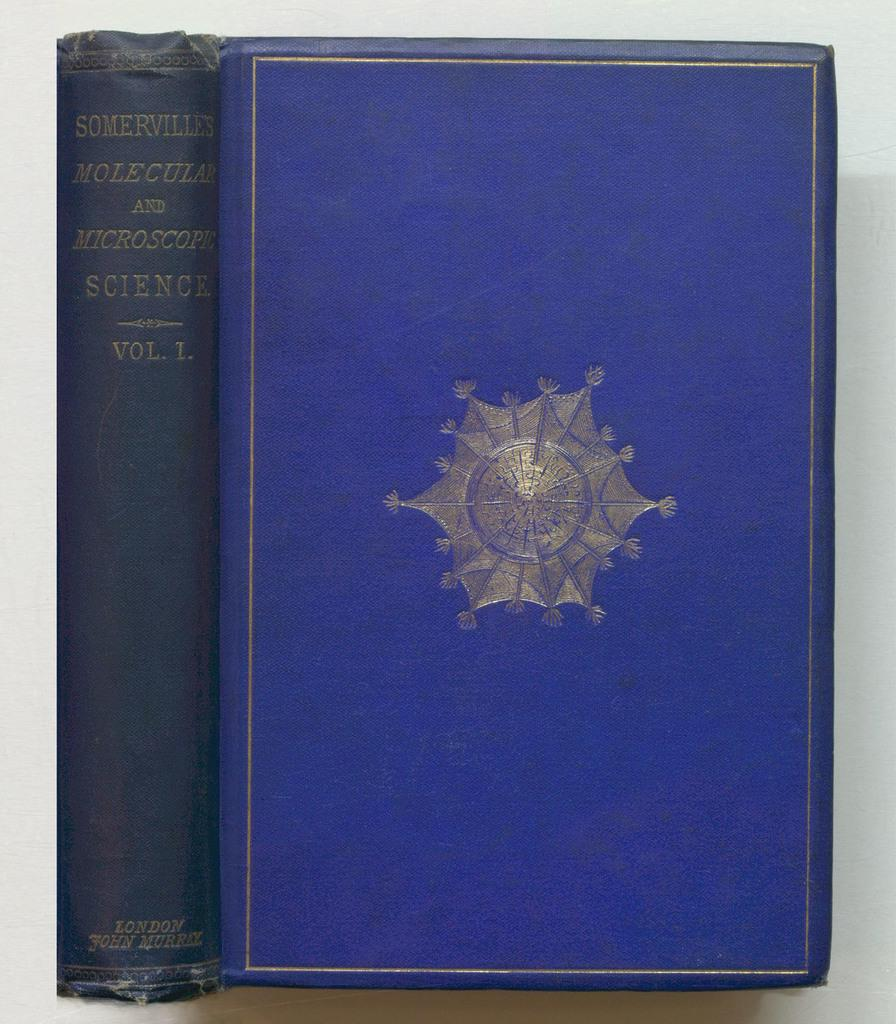Provide a one-sentence caption for the provided image. A two view close up of a old looking book called Somervilles Molecular and Microscope science. 